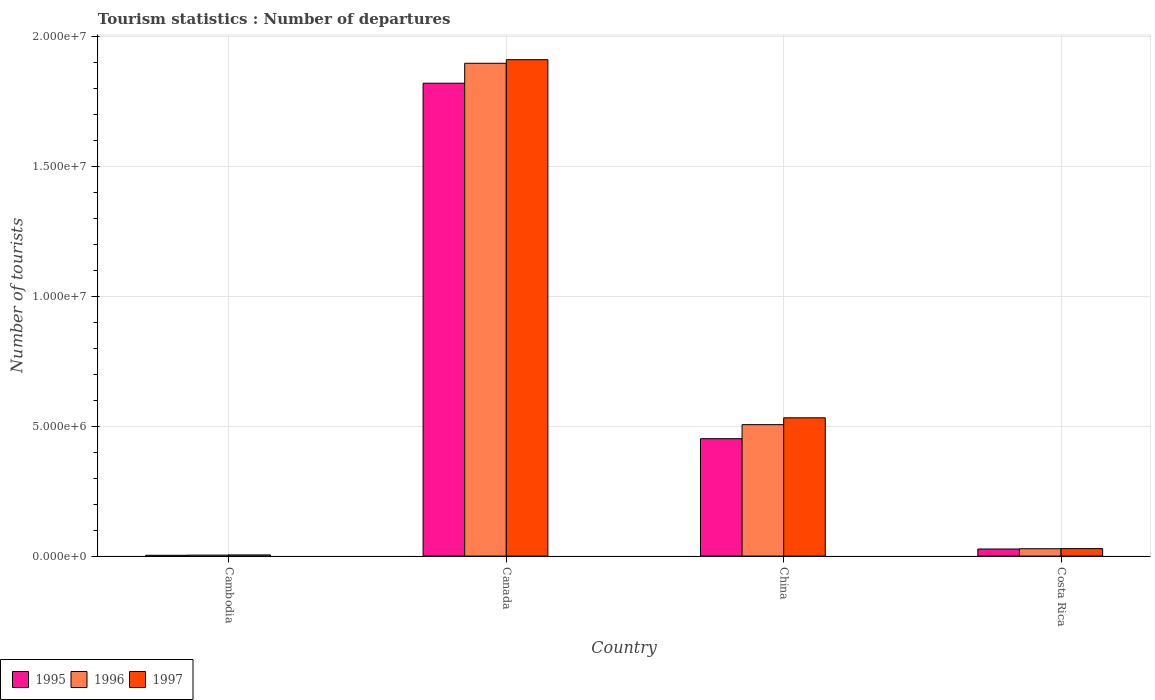How many different coloured bars are there?
Your answer should be compact. 3. How many groups of bars are there?
Your response must be concise. 4. How many bars are there on the 2nd tick from the left?
Give a very brief answer. 3. What is the number of tourist departures in 1997 in Cambodia?
Keep it short and to the point. 4.50e+04. Across all countries, what is the maximum number of tourist departures in 1995?
Make the answer very short. 1.82e+07. Across all countries, what is the minimum number of tourist departures in 1997?
Ensure brevity in your answer.  4.50e+04. In which country was the number of tourist departures in 1995 maximum?
Ensure brevity in your answer.  Canada. In which country was the number of tourist departures in 1997 minimum?
Provide a short and direct response. Cambodia. What is the total number of tourist departures in 1995 in the graph?
Your answer should be very brief. 2.30e+07. What is the difference between the number of tourist departures in 1995 in Cambodia and that in China?
Give a very brief answer. -4.49e+06. What is the difference between the number of tourist departures in 1997 in Canada and the number of tourist departures in 1996 in China?
Your response must be concise. 1.40e+07. What is the average number of tourist departures in 1997 per country?
Offer a very short reply. 6.19e+06. What is the difference between the number of tourist departures of/in 1997 and number of tourist departures of/in 1995 in Cambodia?
Provide a short and direct response. 1.40e+04. What is the ratio of the number of tourist departures in 1995 in China to that in Costa Rica?
Keep it short and to the point. 16.56. Is the difference between the number of tourist departures in 1997 in Cambodia and Costa Rica greater than the difference between the number of tourist departures in 1995 in Cambodia and Costa Rica?
Provide a short and direct response. No. What is the difference between the highest and the second highest number of tourist departures in 1997?
Give a very brief answer. 1.88e+07. What is the difference between the highest and the lowest number of tourist departures in 1995?
Your answer should be very brief. 1.82e+07. What does the 1st bar from the right in China represents?
Keep it short and to the point. 1997. Is it the case that in every country, the sum of the number of tourist departures in 1996 and number of tourist departures in 1997 is greater than the number of tourist departures in 1995?
Ensure brevity in your answer.  Yes. How many bars are there?
Keep it short and to the point. 12. Does the graph contain any zero values?
Ensure brevity in your answer.  No. Does the graph contain grids?
Provide a short and direct response. Yes. How are the legend labels stacked?
Ensure brevity in your answer.  Horizontal. What is the title of the graph?
Offer a very short reply. Tourism statistics : Number of departures. Does "2002" appear as one of the legend labels in the graph?
Provide a short and direct response. No. What is the label or title of the X-axis?
Offer a very short reply. Country. What is the label or title of the Y-axis?
Offer a very short reply. Number of tourists. What is the Number of tourists of 1995 in Cambodia?
Provide a succinct answer. 3.10e+04. What is the Number of tourists of 1996 in Cambodia?
Ensure brevity in your answer.  3.80e+04. What is the Number of tourists of 1997 in Cambodia?
Offer a terse response. 4.50e+04. What is the Number of tourists in 1995 in Canada?
Your answer should be compact. 1.82e+07. What is the Number of tourists in 1996 in Canada?
Your answer should be very brief. 1.90e+07. What is the Number of tourists in 1997 in Canada?
Your response must be concise. 1.91e+07. What is the Number of tourists in 1995 in China?
Your answer should be compact. 4.52e+06. What is the Number of tourists in 1996 in China?
Your response must be concise. 5.06e+06. What is the Number of tourists in 1997 in China?
Offer a very short reply. 5.32e+06. What is the Number of tourists of 1995 in Costa Rica?
Ensure brevity in your answer.  2.73e+05. What is the Number of tourists in 1996 in Costa Rica?
Offer a very short reply. 2.83e+05. What is the Number of tourists of 1997 in Costa Rica?
Provide a succinct answer. 2.88e+05. Across all countries, what is the maximum Number of tourists in 1995?
Provide a short and direct response. 1.82e+07. Across all countries, what is the maximum Number of tourists in 1996?
Ensure brevity in your answer.  1.90e+07. Across all countries, what is the maximum Number of tourists of 1997?
Offer a terse response. 1.91e+07. Across all countries, what is the minimum Number of tourists in 1995?
Keep it short and to the point. 3.10e+04. Across all countries, what is the minimum Number of tourists in 1996?
Make the answer very short. 3.80e+04. Across all countries, what is the minimum Number of tourists in 1997?
Make the answer very short. 4.50e+04. What is the total Number of tourists in 1995 in the graph?
Ensure brevity in your answer.  2.30e+07. What is the total Number of tourists of 1996 in the graph?
Your answer should be very brief. 2.44e+07. What is the total Number of tourists in 1997 in the graph?
Make the answer very short. 2.48e+07. What is the difference between the Number of tourists in 1995 in Cambodia and that in Canada?
Your response must be concise. -1.82e+07. What is the difference between the Number of tourists of 1996 in Cambodia and that in Canada?
Your answer should be very brief. -1.89e+07. What is the difference between the Number of tourists in 1997 in Cambodia and that in Canada?
Your answer should be compact. -1.91e+07. What is the difference between the Number of tourists of 1995 in Cambodia and that in China?
Your answer should be very brief. -4.49e+06. What is the difference between the Number of tourists of 1996 in Cambodia and that in China?
Ensure brevity in your answer.  -5.02e+06. What is the difference between the Number of tourists in 1997 in Cambodia and that in China?
Your response must be concise. -5.28e+06. What is the difference between the Number of tourists in 1995 in Cambodia and that in Costa Rica?
Offer a terse response. -2.42e+05. What is the difference between the Number of tourists of 1996 in Cambodia and that in Costa Rica?
Offer a very short reply. -2.45e+05. What is the difference between the Number of tourists of 1997 in Cambodia and that in Costa Rica?
Provide a succinct answer. -2.43e+05. What is the difference between the Number of tourists of 1995 in Canada and that in China?
Your answer should be very brief. 1.37e+07. What is the difference between the Number of tourists in 1996 in Canada and that in China?
Ensure brevity in your answer.  1.39e+07. What is the difference between the Number of tourists in 1997 in Canada and that in China?
Make the answer very short. 1.38e+07. What is the difference between the Number of tourists of 1995 in Canada and that in Costa Rica?
Ensure brevity in your answer.  1.79e+07. What is the difference between the Number of tourists of 1996 in Canada and that in Costa Rica?
Give a very brief answer. 1.87e+07. What is the difference between the Number of tourists in 1997 in Canada and that in Costa Rica?
Provide a short and direct response. 1.88e+07. What is the difference between the Number of tourists of 1995 in China and that in Costa Rica?
Provide a short and direct response. 4.25e+06. What is the difference between the Number of tourists in 1996 in China and that in Costa Rica?
Provide a succinct answer. 4.78e+06. What is the difference between the Number of tourists in 1997 in China and that in Costa Rica?
Your answer should be very brief. 5.04e+06. What is the difference between the Number of tourists of 1995 in Cambodia and the Number of tourists of 1996 in Canada?
Ensure brevity in your answer.  -1.89e+07. What is the difference between the Number of tourists in 1995 in Cambodia and the Number of tourists in 1997 in Canada?
Offer a terse response. -1.91e+07. What is the difference between the Number of tourists of 1996 in Cambodia and the Number of tourists of 1997 in Canada?
Give a very brief answer. -1.91e+07. What is the difference between the Number of tourists in 1995 in Cambodia and the Number of tourists in 1996 in China?
Provide a short and direct response. -5.03e+06. What is the difference between the Number of tourists of 1995 in Cambodia and the Number of tourists of 1997 in China?
Offer a very short reply. -5.29e+06. What is the difference between the Number of tourists of 1996 in Cambodia and the Number of tourists of 1997 in China?
Your answer should be compact. -5.29e+06. What is the difference between the Number of tourists of 1995 in Cambodia and the Number of tourists of 1996 in Costa Rica?
Keep it short and to the point. -2.52e+05. What is the difference between the Number of tourists of 1995 in Cambodia and the Number of tourists of 1997 in Costa Rica?
Keep it short and to the point. -2.57e+05. What is the difference between the Number of tourists in 1996 in Cambodia and the Number of tourists in 1997 in Costa Rica?
Provide a short and direct response. -2.50e+05. What is the difference between the Number of tourists of 1995 in Canada and the Number of tourists of 1996 in China?
Keep it short and to the point. 1.31e+07. What is the difference between the Number of tourists of 1995 in Canada and the Number of tourists of 1997 in China?
Offer a very short reply. 1.29e+07. What is the difference between the Number of tourists in 1996 in Canada and the Number of tourists in 1997 in China?
Ensure brevity in your answer.  1.36e+07. What is the difference between the Number of tourists of 1995 in Canada and the Number of tourists of 1996 in Costa Rica?
Your response must be concise. 1.79e+07. What is the difference between the Number of tourists in 1995 in Canada and the Number of tourists in 1997 in Costa Rica?
Ensure brevity in your answer.  1.79e+07. What is the difference between the Number of tourists of 1996 in Canada and the Number of tourists of 1997 in Costa Rica?
Provide a short and direct response. 1.87e+07. What is the difference between the Number of tourists in 1995 in China and the Number of tourists in 1996 in Costa Rica?
Keep it short and to the point. 4.24e+06. What is the difference between the Number of tourists in 1995 in China and the Number of tourists in 1997 in Costa Rica?
Your response must be concise. 4.23e+06. What is the difference between the Number of tourists in 1996 in China and the Number of tourists in 1997 in Costa Rica?
Provide a short and direct response. 4.77e+06. What is the average Number of tourists in 1995 per country?
Ensure brevity in your answer.  5.76e+06. What is the average Number of tourists of 1996 per country?
Your answer should be compact. 6.09e+06. What is the average Number of tourists in 1997 per country?
Give a very brief answer. 6.19e+06. What is the difference between the Number of tourists in 1995 and Number of tourists in 1996 in Cambodia?
Provide a succinct answer. -7000. What is the difference between the Number of tourists in 1995 and Number of tourists in 1997 in Cambodia?
Offer a terse response. -1.40e+04. What is the difference between the Number of tourists in 1996 and Number of tourists in 1997 in Cambodia?
Ensure brevity in your answer.  -7000. What is the difference between the Number of tourists in 1995 and Number of tourists in 1996 in Canada?
Ensure brevity in your answer.  -7.67e+05. What is the difference between the Number of tourists of 1995 and Number of tourists of 1997 in Canada?
Offer a terse response. -9.05e+05. What is the difference between the Number of tourists in 1996 and Number of tourists in 1997 in Canada?
Ensure brevity in your answer.  -1.38e+05. What is the difference between the Number of tourists of 1995 and Number of tourists of 1996 in China?
Offer a terse response. -5.41e+05. What is the difference between the Number of tourists of 1995 and Number of tourists of 1997 in China?
Your answer should be compact. -8.04e+05. What is the difference between the Number of tourists of 1996 and Number of tourists of 1997 in China?
Your response must be concise. -2.63e+05. What is the difference between the Number of tourists in 1995 and Number of tourists in 1996 in Costa Rica?
Provide a succinct answer. -10000. What is the difference between the Number of tourists in 1995 and Number of tourists in 1997 in Costa Rica?
Your response must be concise. -1.50e+04. What is the difference between the Number of tourists of 1996 and Number of tourists of 1997 in Costa Rica?
Your answer should be very brief. -5000. What is the ratio of the Number of tourists in 1995 in Cambodia to that in Canada?
Offer a very short reply. 0. What is the ratio of the Number of tourists of 1996 in Cambodia to that in Canada?
Your answer should be compact. 0. What is the ratio of the Number of tourists in 1997 in Cambodia to that in Canada?
Ensure brevity in your answer.  0. What is the ratio of the Number of tourists in 1995 in Cambodia to that in China?
Give a very brief answer. 0.01. What is the ratio of the Number of tourists of 1996 in Cambodia to that in China?
Offer a terse response. 0.01. What is the ratio of the Number of tourists in 1997 in Cambodia to that in China?
Offer a terse response. 0.01. What is the ratio of the Number of tourists of 1995 in Cambodia to that in Costa Rica?
Your answer should be very brief. 0.11. What is the ratio of the Number of tourists in 1996 in Cambodia to that in Costa Rica?
Give a very brief answer. 0.13. What is the ratio of the Number of tourists in 1997 in Cambodia to that in Costa Rica?
Your answer should be very brief. 0.16. What is the ratio of the Number of tourists in 1995 in Canada to that in China?
Give a very brief answer. 4.03. What is the ratio of the Number of tourists of 1996 in Canada to that in China?
Keep it short and to the point. 3.75. What is the ratio of the Number of tourists of 1997 in Canada to that in China?
Provide a short and direct response. 3.59. What is the ratio of the Number of tourists of 1995 in Canada to that in Costa Rica?
Ensure brevity in your answer.  66.69. What is the ratio of the Number of tourists of 1996 in Canada to that in Costa Rica?
Provide a short and direct response. 67.04. What is the ratio of the Number of tourists of 1997 in Canada to that in Costa Rica?
Provide a short and direct response. 66.36. What is the ratio of the Number of tourists in 1995 in China to that in Costa Rica?
Your answer should be compact. 16.56. What is the ratio of the Number of tourists in 1996 in China to that in Costa Rica?
Offer a very short reply. 17.88. What is the ratio of the Number of tourists of 1997 in China to that in Costa Rica?
Make the answer very short. 18.49. What is the difference between the highest and the second highest Number of tourists of 1995?
Offer a terse response. 1.37e+07. What is the difference between the highest and the second highest Number of tourists in 1996?
Keep it short and to the point. 1.39e+07. What is the difference between the highest and the second highest Number of tourists in 1997?
Offer a terse response. 1.38e+07. What is the difference between the highest and the lowest Number of tourists of 1995?
Keep it short and to the point. 1.82e+07. What is the difference between the highest and the lowest Number of tourists of 1996?
Your response must be concise. 1.89e+07. What is the difference between the highest and the lowest Number of tourists in 1997?
Your answer should be compact. 1.91e+07. 